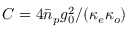Convert formula to latex. <formula><loc_0><loc_0><loc_500><loc_500>C = 4 \bar { n } _ { p } g _ { 0 } ^ { 2 } / ( \kappa _ { e } \kappa _ { o } )</formula> 